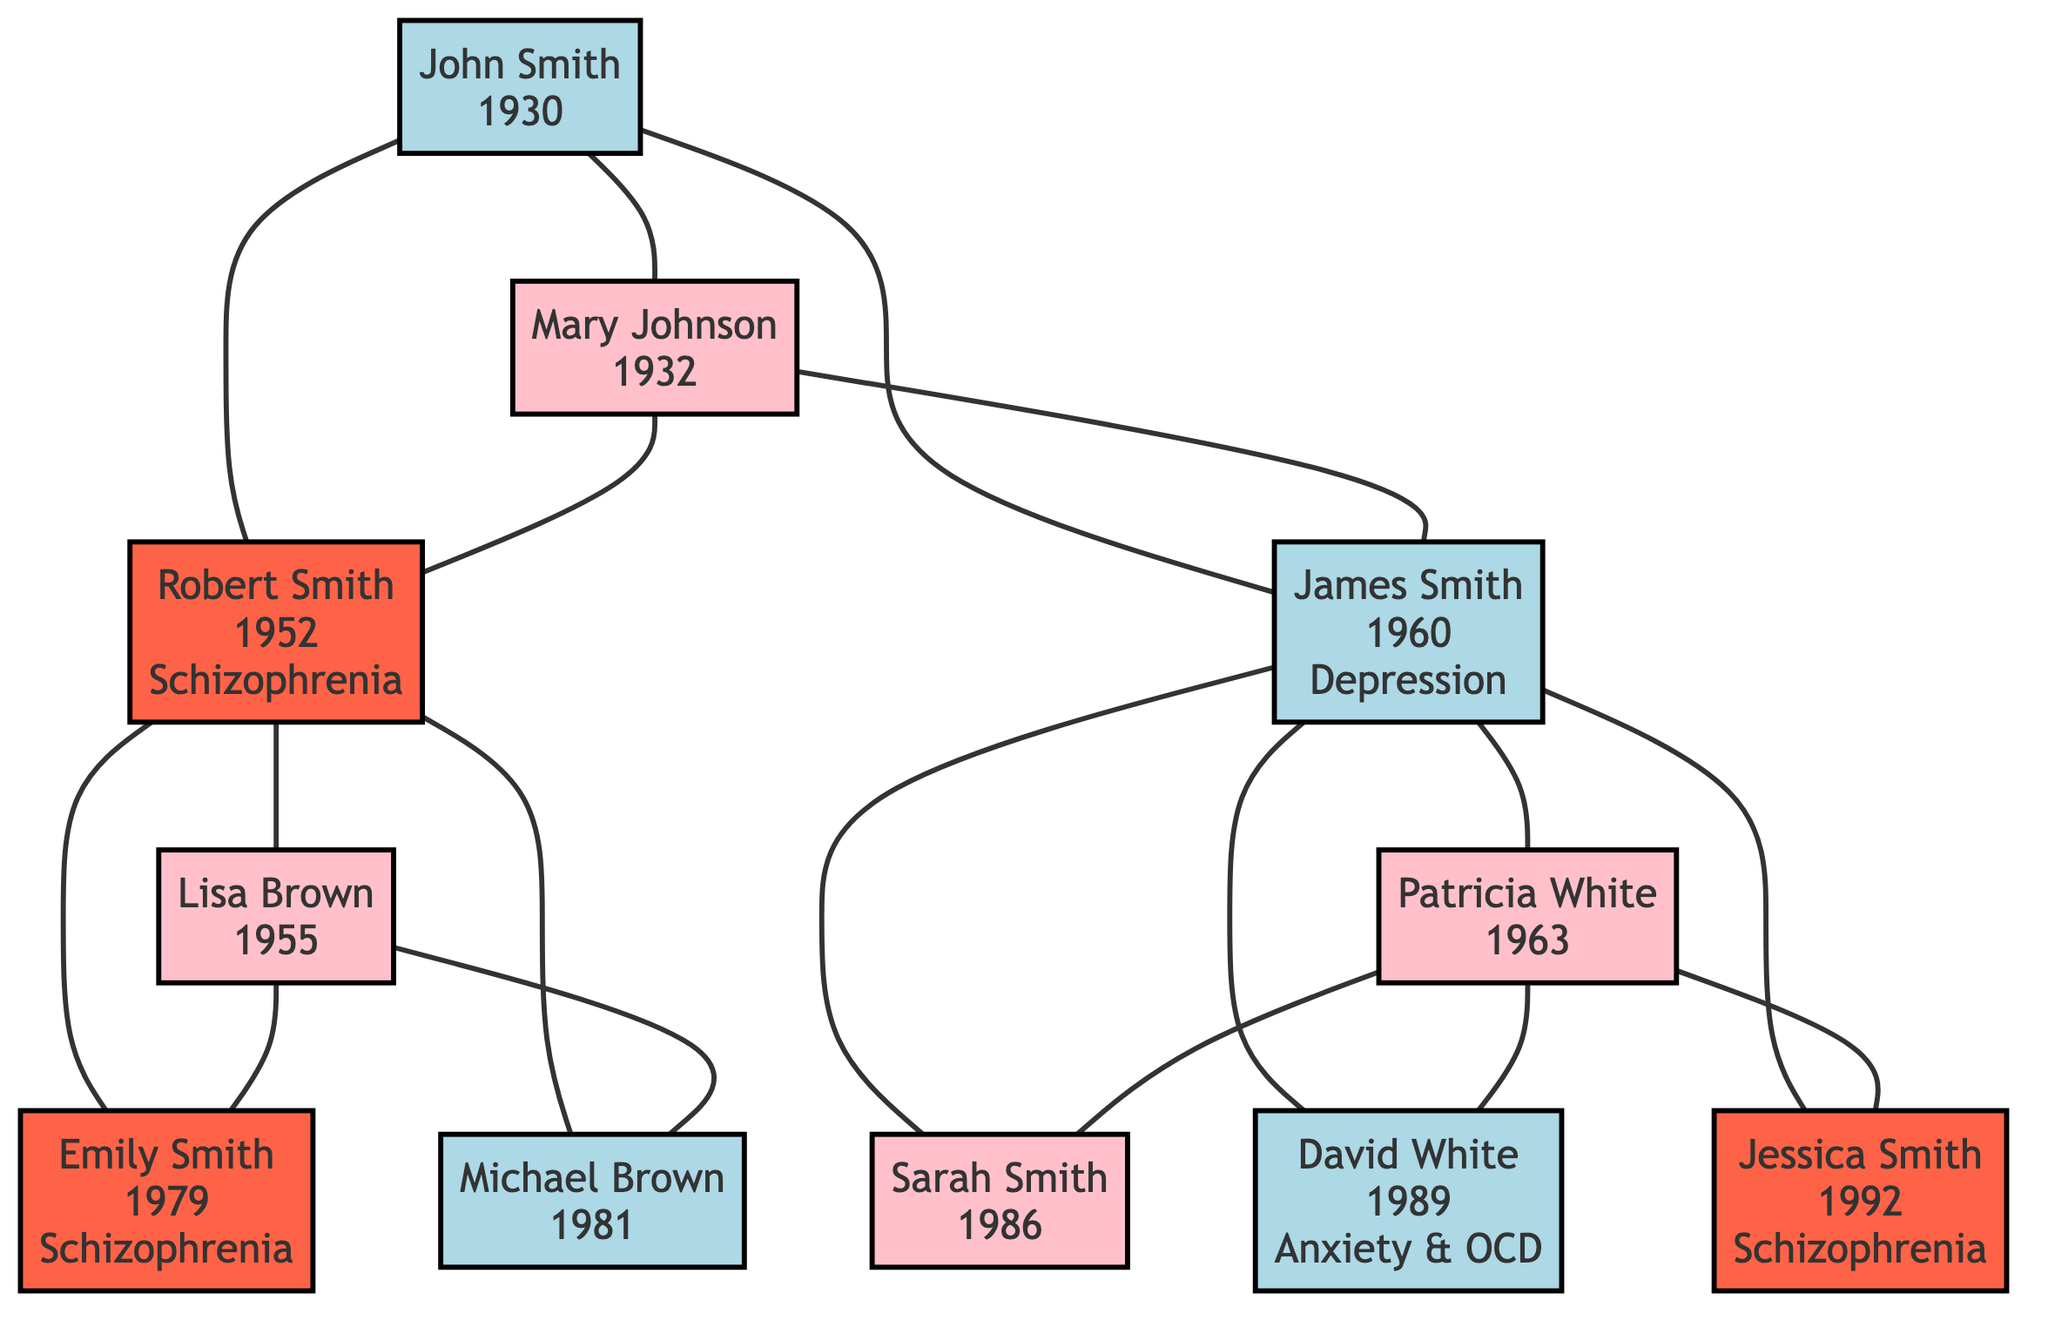What is the birth year of Robert Smith? The diagram lists Robert Smith's birth year directly next to his name in the Generation 2 section. It shows that he was born in 1952.
Answer: 1952 How many individuals in Generation 3 have a diagnosis of schizophrenia? In Generation 3, there are three individuals: Emily Smith, and Jessica Smith, both of whom are marked as having schizophrenia diagnoses. Hence, the total is two diagnosed individuals.
Answer: 2 What relation is Lisa Brown to Robert Smith? The diagram shows that both individuals belong to the same generation, Generation 2, and Lisa Brown is connected to Robert Smith as his partner (as indicated by their direct line).
Answer: Partner What is the common mental health diagnosis among the individuals in Generation 3? Upon examining the diagnoses of Generation 3 individuals, both Emily Smith and Jessica Smith are noted to have schizophrenia, while others have different disorders. Therefore, the common diagnosis is schizophrenia.
Answer: Schizophrenia Which individual diagnosed with schizophrenia in Generation 2 has a triggering event noted? In the Generation 2 section, Robert Smith is mentioned to have been diagnosed with schizophrenia at age 24, with the diagnosis triggered by a major life stressor, making him the only mentioned case here.
Answer: Robert Smith How many individuals in the family tree have a documented history of mental disorders? After reviewing all individuals across generations, only Robert Smith, Emily Smith, and Jessica Smith have documented histories of mental disorders (schizophrenia), while John Smith and Lisa Brown have no mental disorders documented. Therefore, the total is three individuals.
Answer: 3 What year was Jessica Smith diagnosed with schizophrenia? According to the diagram, Jessica Smith was diagnosed at the age of 18, which correlates to her birth year of 1992, making her diagnosis year 2010.
Answer: 2010 Who is the first diagnosed individual in the family tree? Robert Smith is the first individual identified with a schizophrenia diagnosis, occurring in Generation 2 at age 24. Thus, he is the first in the family tree with such a diagnosis.
Answer: Robert Smith What type of mental disorder does David White have? The diagram specifies that David White was noted to have anxiety and obsessive-compulsive disorder, which provides the answer regarding his mental health condition.
Answer: Anxiety & OCD 